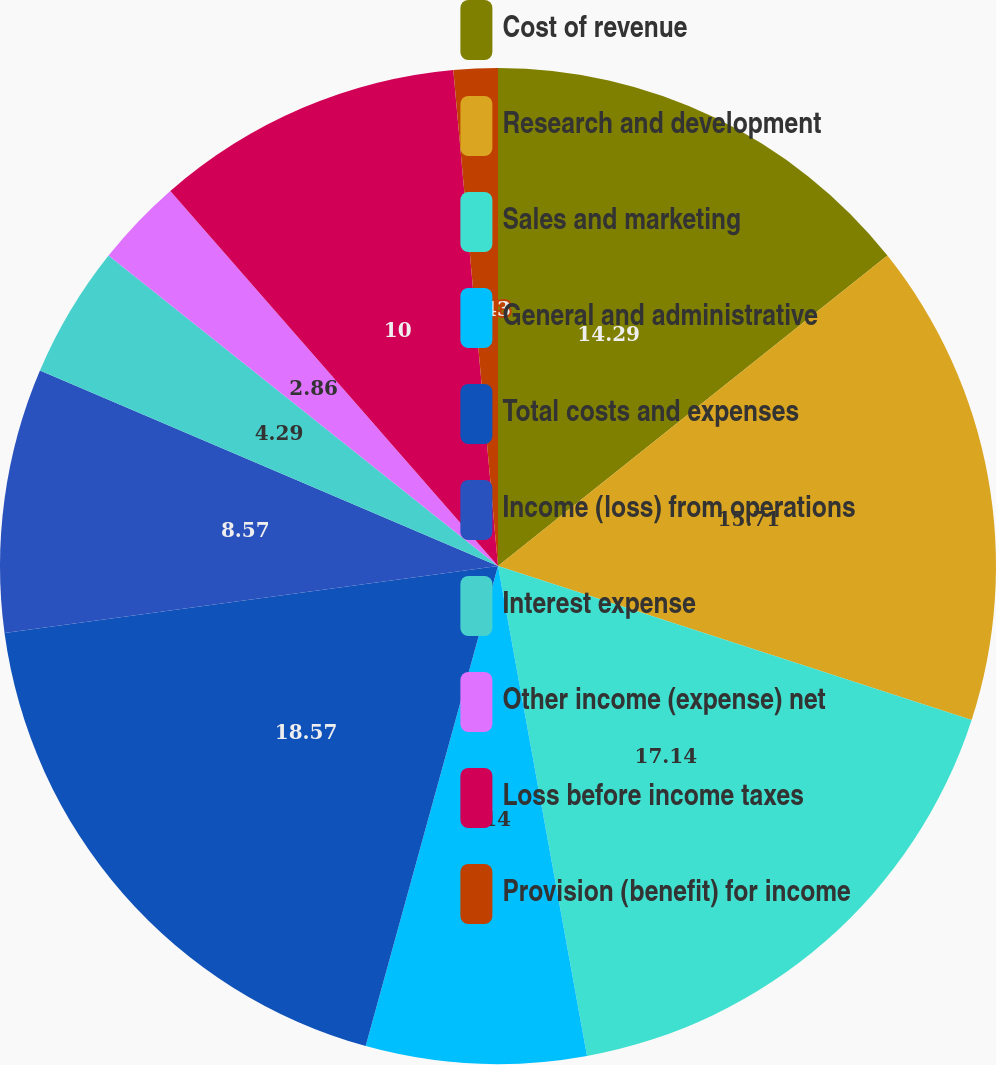<chart> <loc_0><loc_0><loc_500><loc_500><pie_chart><fcel>Cost of revenue<fcel>Research and development<fcel>Sales and marketing<fcel>General and administrative<fcel>Total costs and expenses<fcel>Income (loss) from operations<fcel>Interest expense<fcel>Other income (expense) net<fcel>Loss before income taxes<fcel>Provision (benefit) for income<nl><fcel>14.29%<fcel>15.71%<fcel>17.14%<fcel>7.14%<fcel>18.57%<fcel>8.57%<fcel>4.29%<fcel>2.86%<fcel>10.0%<fcel>1.43%<nl></chart> 